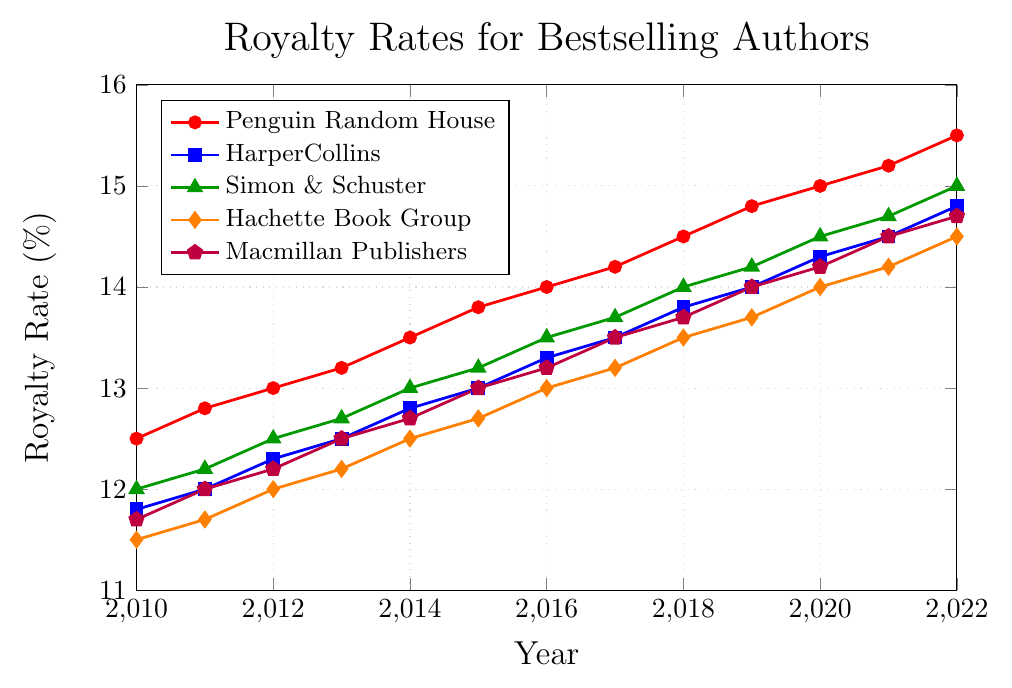Which publisher's royalty rate has increased the most from 2010 to 2022? Compare the royalty rates in 2010 and 2022 for each publisher. For Penguin Random House, the increase is 15.5 - 12.5 = 3.0%. For HarperCollins, it's 14.8 - 11.8 = 3.0%. For Simon & Schuster, it's 15.0 - 12.0 = 3.0%. For Hachette Book Group, it's 14.5 - 11.5 = 3.0%. For Macmillan Publishers, it's 14.7 - 11.7 = 3.0%. Thus, all publishers have had an equal increase.
Answer: All publishers What is the average royalty rate for Penguin Random House between 2010 and 2022? Add all the royalty rates for Penguin Random House from 2010 to 2022 and divide by the number of years (13): (12.5 + 12.8 + 13.0 + 13.2 + 13.5 + 13.8 + 14.0 + 14.2 + 14.5 + 14.8 + 15.0 + 15.2 + 15.5) / 13 = 13.92%
Answer: 13.92% Which publisher had the lowest royalty rate in 2010? Look at the data for 2010 and identify the lowest value: Hachette Book Group had 11.5%, which is the lowest among all publishers.
Answer: Hachette Book Group How does the royalty rate trend of Simon & Schuster compare to that of HarperCollins between 2010 and 2022? Both Simon & Schuster and HarperCollins show a consistent increasing trend over the period. Comparing year by year, both publishers see gradual increments, with Simon & Schuster generally showing slightly higher rates than HarperCollins in most years.
Answer: Both increasing, Simon & Schuster generally higher Which publisher's royalty rate increased the fastest between 2018 and 2020? Compare the changes between 2018 and 2020 for each publisher. Penguin Random House increased by 15.0 - 14.5 = 0.5%. HarperCollins increased by 14.3 - 13.8 = 0.5%. Simon & Schuster increased by 14.5 - 14.0 = 0.5%. Hachette Book Group increased by 14.0 - 13.5 = 0.5%. Macmillan Publishers increased by 14.2 - 13.7 = 0.5%. They all increased by 0.5% in this period.
Answer: All publishers equally Among the publishers, did any share the same royalty rate in any year? If so, when? Check the data for each year to find any matching values. In 2010, no matching values. In 2011, HarperCollins and Macmillan Publishers both have 12.0%. In 2012, Simon & Schuster and Macmillan Publishers both have 12.2%. No other matching values in subsequent years.
Answer: HarperCollins and Macmillan Publishers in 2011, Simon & Schuster and Macmillan Publishers in 2012 What's the highest royalty rate observed in the entire dataset? Look at all the values and identify the highest value, which is Penguin Random House in 2022 at 15.5%.
Answer: 15.5% Who had the highest average annual royalty rate increase between 2010 and 2022? Calculate the average annual increase for each publisher. Penguin Random House: (15.5 - 12.5) / 12 = 0.25%. HarperCollins: (14.8 - 11.8) / 12 = 0.25%. Simon & Schuster: (15.0 - 12.0) / 12 = 0.25%. Hachette Book Group: (14.5 - 11.5) / 12 = 0.25%. Macmillan Publishers: (14.7 - 11.7) / 12 = 0.25%. All publishers have the same average annual increase of 0.25%.
Answer: All publishers equally When did HarperCollins' royalty rate first surpass 14%? Look at the provided data for the years when HarperCollins' royalty rate first exceeds 14%. In 2019, it reached 14.0% and in 2020 it surpassed at 14.3%.
Answer: 2020 